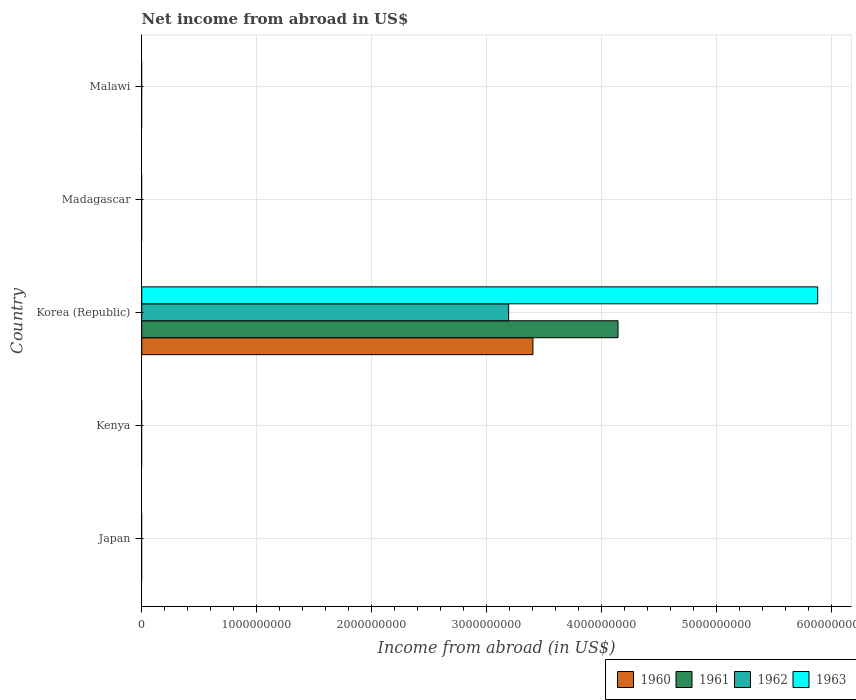Are the number of bars per tick equal to the number of legend labels?
Keep it short and to the point. No. Are the number of bars on each tick of the Y-axis equal?
Provide a short and direct response. No. How many bars are there on the 2nd tick from the bottom?
Your answer should be compact. 0. What is the label of the 2nd group of bars from the top?
Offer a very short reply. Madagascar. In how many cases, is the number of bars for a given country not equal to the number of legend labels?
Give a very brief answer. 4. What is the net income from abroad in 1963 in Kenya?
Your answer should be very brief. 0. Across all countries, what is the maximum net income from abroad in 1960?
Your answer should be very brief. 3.40e+09. In which country was the net income from abroad in 1963 maximum?
Offer a terse response. Korea (Republic). What is the total net income from abroad in 1963 in the graph?
Make the answer very short. 5.88e+09. What is the difference between the net income from abroad in 1960 in Korea (Republic) and the net income from abroad in 1962 in Madagascar?
Provide a short and direct response. 3.40e+09. What is the average net income from abroad in 1962 per country?
Give a very brief answer. 6.38e+08. What is the difference between the net income from abroad in 1961 and net income from abroad in 1962 in Korea (Republic)?
Your response must be concise. 9.52e+08. What is the difference between the highest and the lowest net income from abroad in 1961?
Your answer should be very brief. 4.14e+09. In how many countries, is the net income from abroad in 1960 greater than the average net income from abroad in 1960 taken over all countries?
Your answer should be very brief. 1. Is it the case that in every country, the sum of the net income from abroad in 1963 and net income from abroad in 1961 is greater than the sum of net income from abroad in 1962 and net income from abroad in 1960?
Provide a succinct answer. No. How many bars are there?
Your answer should be compact. 4. How many countries are there in the graph?
Ensure brevity in your answer.  5. What is the difference between two consecutive major ticks on the X-axis?
Your answer should be compact. 1.00e+09. Are the values on the major ticks of X-axis written in scientific E-notation?
Provide a short and direct response. No. How many legend labels are there?
Provide a short and direct response. 4. What is the title of the graph?
Offer a very short reply. Net income from abroad in US$. Does "2004" appear as one of the legend labels in the graph?
Your response must be concise. No. What is the label or title of the X-axis?
Give a very brief answer. Income from abroad (in US$). What is the Income from abroad (in US$) in 1962 in Japan?
Your answer should be compact. 0. What is the Income from abroad (in US$) of 1961 in Kenya?
Provide a succinct answer. 0. What is the Income from abroad (in US$) of 1963 in Kenya?
Keep it short and to the point. 0. What is the Income from abroad (in US$) in 1960 in Korea (Republic)?
Keep it short and to the point. 3.40e+09. What is the Income from abroad (in US$) of 1961 in Korea (Republic)?
Offer a very short reply. 4.14e+09. What is the Income from abroad (in US$) in 1962 in Korea (Republic)?
Offer a very short reply. 3.19e+09. What is the Income from abroad (in US$) of 1963 in Korea (Republic)?
Your answer should be compact. 5.88e+09. What is the Income from abroad (in US$) of 1960 in Madagascar?
Ensure brevity in your answer.  0. What is the Income from abroad (in US$) in 1961 in Madagascar?
Offer a terse response. 0. What is the Income from abroad (in US$) of 1962 in Madagascar?
Your response must be concise. 0. What is the Income from abroad (in US$) of 1962 in Malawi?
Provide a succinct answer. 0. Across all countries, what is the maximum Income from abroad (in US$) in 1960?
Provide a succinct answer. 3.40e+09. Across all countries, what is the maximum Income from abroad (in US$) in 1961?
Offer a very short reply. 4.14e+09. Across all countries, what is the maximum Income from abroad (in US$) in 1962?
Make the answer very short. 3.19e+09. Across all countries, what is the maximum Income from abroad (in US$) of 1963?
Give a very brief answer. 5.88e+09. Across all countries, what is the minimum Income from abroad (in US$) in 1960?
Give a very brief answer. 0. Across all countries, what is the minimum Income from abroad (in US$) in 1963?
Keep it short and to the point. 0. What is the total Income from abroad (in US$) in 1960 in the graph?
Ensure brevity in your answer.  3.40e+09. What is the total Income from abroad (in US$) of 1961 in the graph?
Keep it short and to the point. 4.14e+09. What is the total Income from abroad (in US$) of 1962 in the graph?
Provide a short and direct response. 3.19e+09. What is the total Income from abroad (in US$) of 1963 in the graph?
Your answer should be very brief. 5.88e+09. What is the average Income from abroad (in US$) of 1960 per country?
Your answer should be compact. 6.81e+08. What is the average Income from abroad (in US$) in 1961 per country?
Offer a very short reply. 8.29e+08. What is the average Income from abroad (in US$) in 1962 per country?
Your response must be concise. 6.38e+08. What is the average Income from abroad (in US$) in 1963 per country?
Offer a terse response. 1.18e+09. What is the difference between the Income from abroad (in US$) of 1960 and Income from abroad (in US$) of 1961 in Korea (Republic)?
Give a very brief answer. -7.40e+08. What is the difference between the Income from abroad (in US$) in 1960 and Income from abroad (in US$) in 1962 in Korea (Republic)?
Give a very brief answer. 2.11e+08. What is the difference between the Income from abroad (in US$) of 1960 and Income from abroad (in US$) of 1963 in Korea (Republic)?
Your answer should be compact. -2.48e+09. What is the difference between the Income from abroad (in US$) in 1961 and Income from abroad (in US$) in 1962 in Korea (Republic)?
Provide a short and direct response. 9.52e+08. What is the difference between the Income from abroad (in US$) in 1961 and Income from abroad (in US$) in 1963 in Korea (Republic)?
Ensure brevity in your answer.  -1.74e+09. What is the difference between the Income from abroad (in US$) of 1962 and Income from abroad (in US$) of 1963 in Korea (Republic)?
Give a very brief answer. -2.69e+09. What is the difference between the highest and the lowest Income from abroad (in US$) of 1960?
Provide a short and direct response. 3.40e+09. What is the difference between the highest and the lowest Income from abroad (in US$) of 1961?
Ensure brevity in your answer.  4.14e+09. What is the difference between the highest and the lowest Income from abroad (in US$) of 1962?
Offer a terse response. 3.19e+09. What is the difference between the highest and the lowest Income from abroad (in US$) in 1963?
Your answer should be compact. 5.88e+09. 